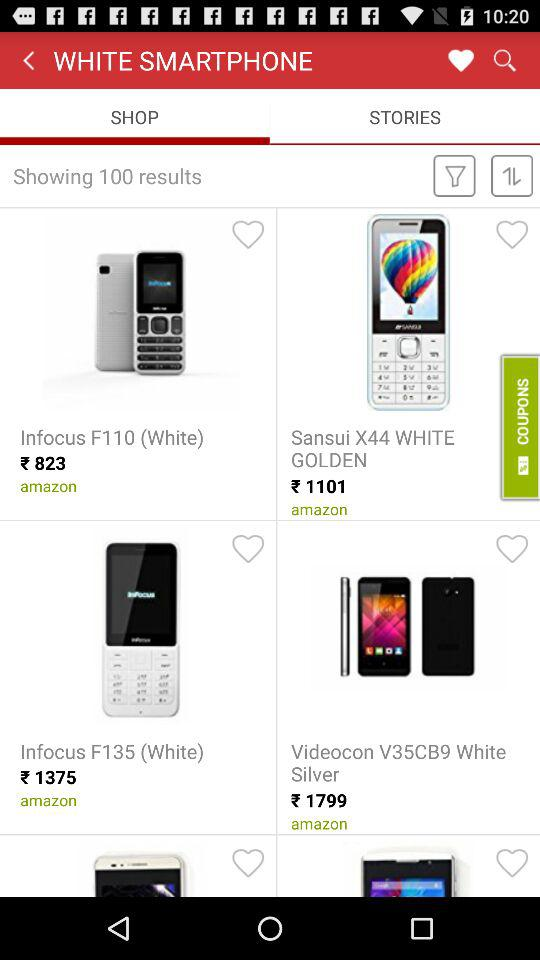Which tab is selected right now? The tab "SHOP" is selected right now. 